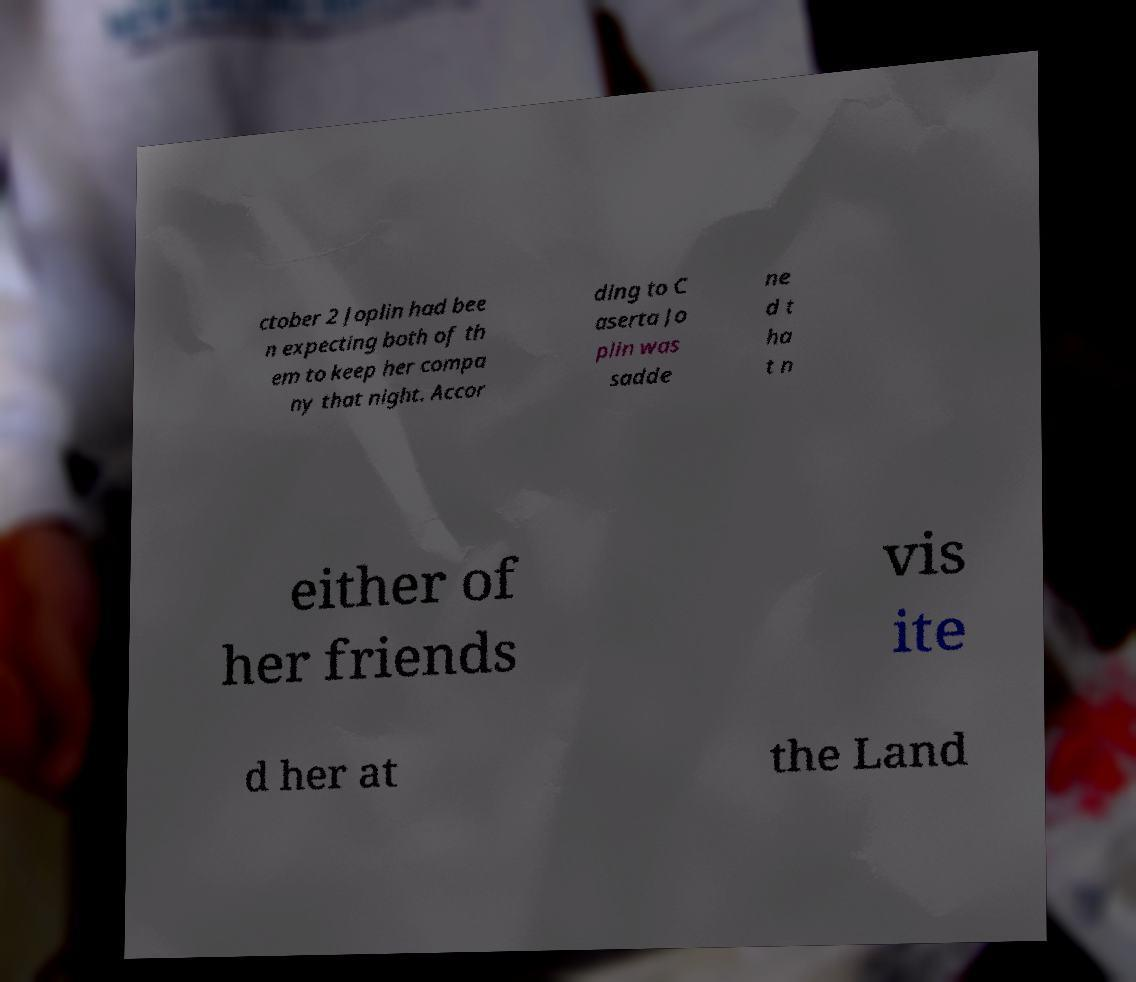I need the written content from this picture converted into text. Can you do that? ctober 2 Joplin had bee n expecting both of th em to keep her compa ny that night. Accor ding to C aserta Jo plin was sadde ne d t ha t n either of her friends vis ite d her at the Land 